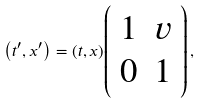Convert formula to latex. <formula><loc_0><loc_0><loc_500><loc_500>\left ( t ^ { \prime } , x ^ { \prime } \right ) = ( t , x ) { \left ( \begin{array} { l l } { 1 } & { v } \\ { 0 } & { 1 } \end{array} \right ) } \, ,</formula> 